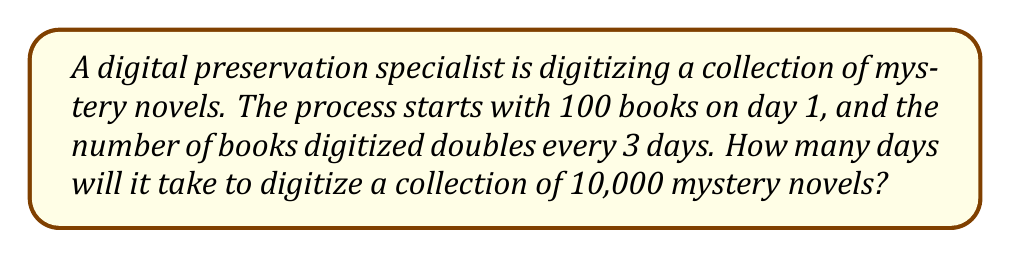Teach me how to tackle this problem. Let's approach this step-by-step using an exponential growth model:

1) The exponential growth function for this scenario is:
   $N(t) = 100 \cdot 2^{\frac{t}{3}}$
   Where $N(t)$ is the number of books digitized after $t$ days.

2) We need to find $t$ when $N(t) = 10,000$. So, we set up the equation:
   $10,000 = 100 \cdot 2^{\frac{t}{3}}$

3) Divide both sides by 100:
   $100 = 2^{\frac{t}{3}}$

4) Take the logarithm (base 2) of both sides:
   $\log_2(100) = \frac{t}{3}$

5) Multiply both sides by 3:
   $3\log_2(100) = t$

6) Calculate:
   $t = 3 \cdot \frac{\log(100)}{\log(2)} \approx 19.93$ days

7) Since we can only work in whole days, we need to round up to the next integer.

Therefore, it will take 20 days to digitize 10,000 mystery novels.
Answer: 20 days 